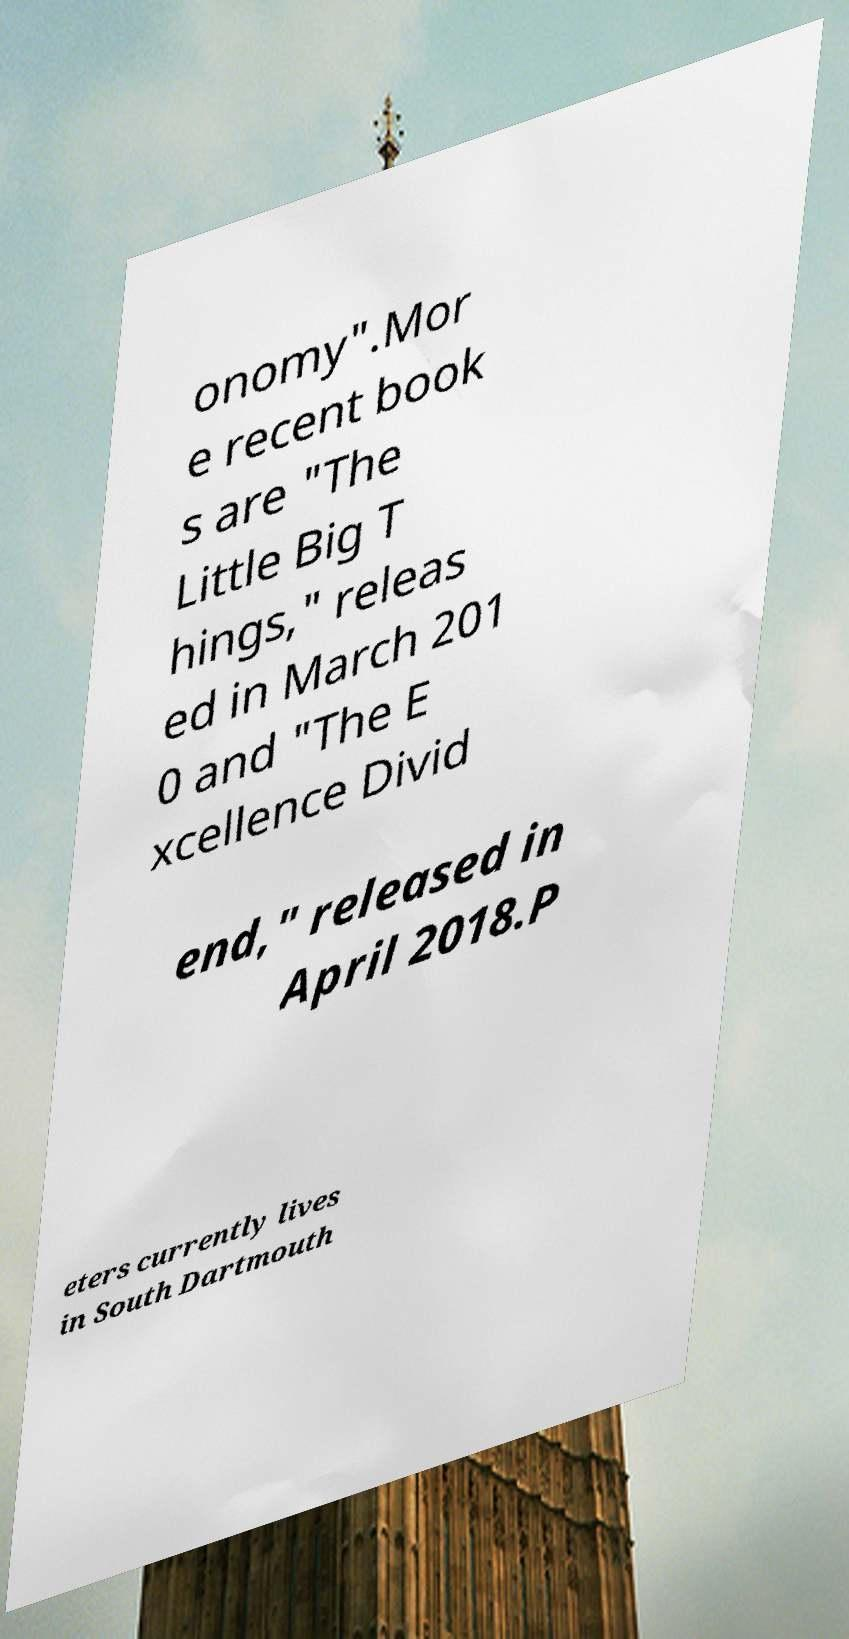Could you extract and type out the text from this image? onomy".Mor e recent book s are "The Little Big T hings," releas ed in March 201 0 and "The E xcellence Divid end," released in April 2018.P eters currently lives in South Dartmouth 